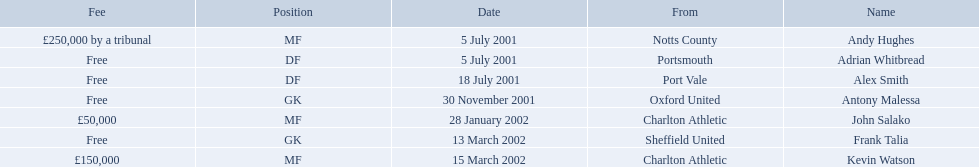Which players in the 2001-02 reading f.c. season played the mf position? Andy Hughes, John Salako, Kevin Watson. Of these players, which ones transferred in 2002? John Salako, Kevin Watson. Of these players, who had the highest transfer fee? Kevin Watson. What was this player's transfer fee? £150,000. Who are all the players? Andy Hughes, Adrian Whitbread, Alex Smith, Antony Malessa, John Salako, Frank Talia, Kevin Watson. Could you help me parse every detail presented in this table? {'header': ['Fee', 'Position', 'Date', 'From', 'Name'], 'rows': [['£250,000 by a tribunal', 'MF', '5 July 2001', 'Notts County', 'Andy Hughes'], ['Free', 'DF', '5 July 2001', 'Portsmouth', 'Adrian Whitbread'], ['Free', 'DF', '18 July 2001', 'Port Vale', 'Alex Smith'], ['Free', 'GK', '30 November 2001', 'Oxford United', 'Antony Malessa'], ['£50,000', 'MF', '28 January 2002', 'Charlton Athletic', 'John Salako'], ['Free', 'GK', '13 March 2002', 'Sheffield United', 'Frank Talia'], ['£150,000', 'MF', '15 March 2002', 'Charlton Athletic', 'Kevin Watson']]} What were their fees? £250,000 by a tribunal, Free, Free, Free, £50,000, Free, £150,000. And how much was kevin watson's fee? £150,000. What are all of the names? Andy Hughes, Adrian Whitbread, Alex Smith, Antony Malessa, John Salako, Frank Talia, Kevin Watson. What was the fee for each person? £250,000 by a tribunal, Free, Free, Free, £50,000, Free, £150,000. And who had the highest fee? Andy Hughes. 